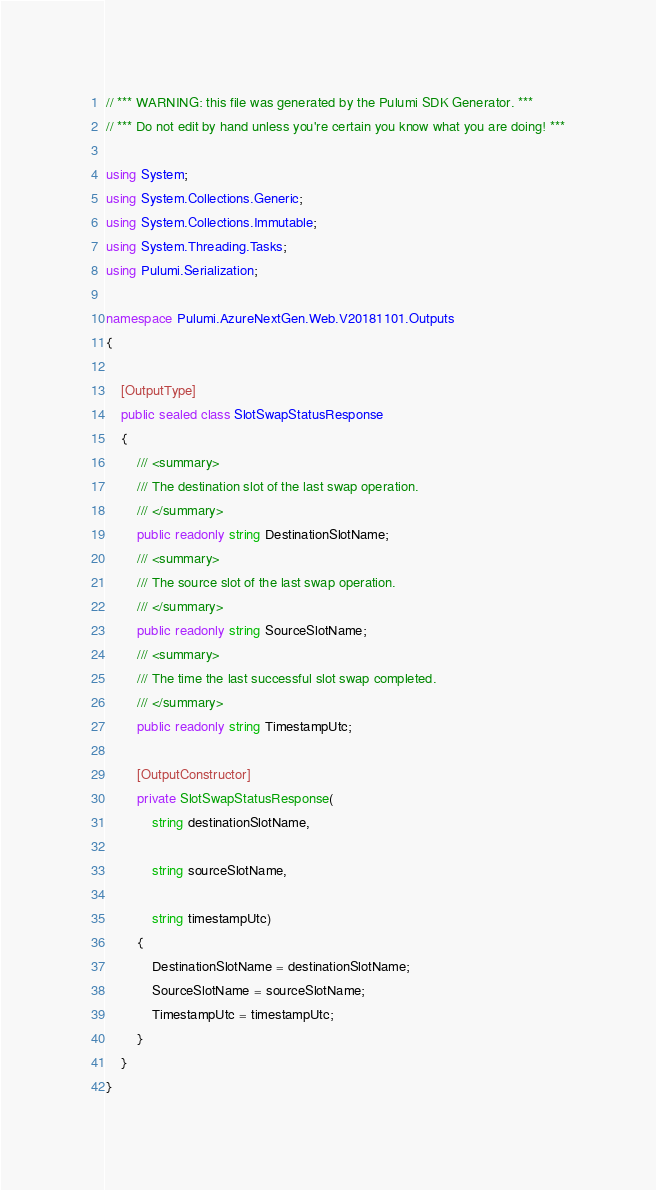Convert code to text. <code><loc_0><loc_0><loc_500><loc_500><_C#_>// *** WARNING: this file was generated by the Pulumi SDK Generator. ***
// *** Do not edit by hand unless you're certain you know what you are doing! ***

using System;
using System.Collections.Generic;
using System.Collections.Immutable;
using System.Threading.Tasks;
using Pulumi.Serialization;

namespace Pulumi.AzureNextGen.Web.V20181101.Outputs
{

    [OutputType]
    public sealed class SlotSwapStatusResponse
    {
        /// <summary>
        /// The destination slot of the last swap operation.
        /// </summary>
        public readonly string DestinationSlotName;
        /// <summary>
        /// The source slot of the last swap operation.
        /// </summary>
        public readonly string SourceSlotName;
        /// <summary>
        /// The time the last successful slot swap completed.
        /// </summary>
        public readonly string TimestampUtc;

        [OutputConstructor]
        private SlotSwapStatusResponse(
            string destinationSlotName,

            string sourceSlotName,

            string timestampUtc)
        {
            DestinationSlotName = destinationSlotName;
            SourceSlotName = sourceSlotName;
            TimestampUtc = timestampUtc;
        }
    }
}
</code> 